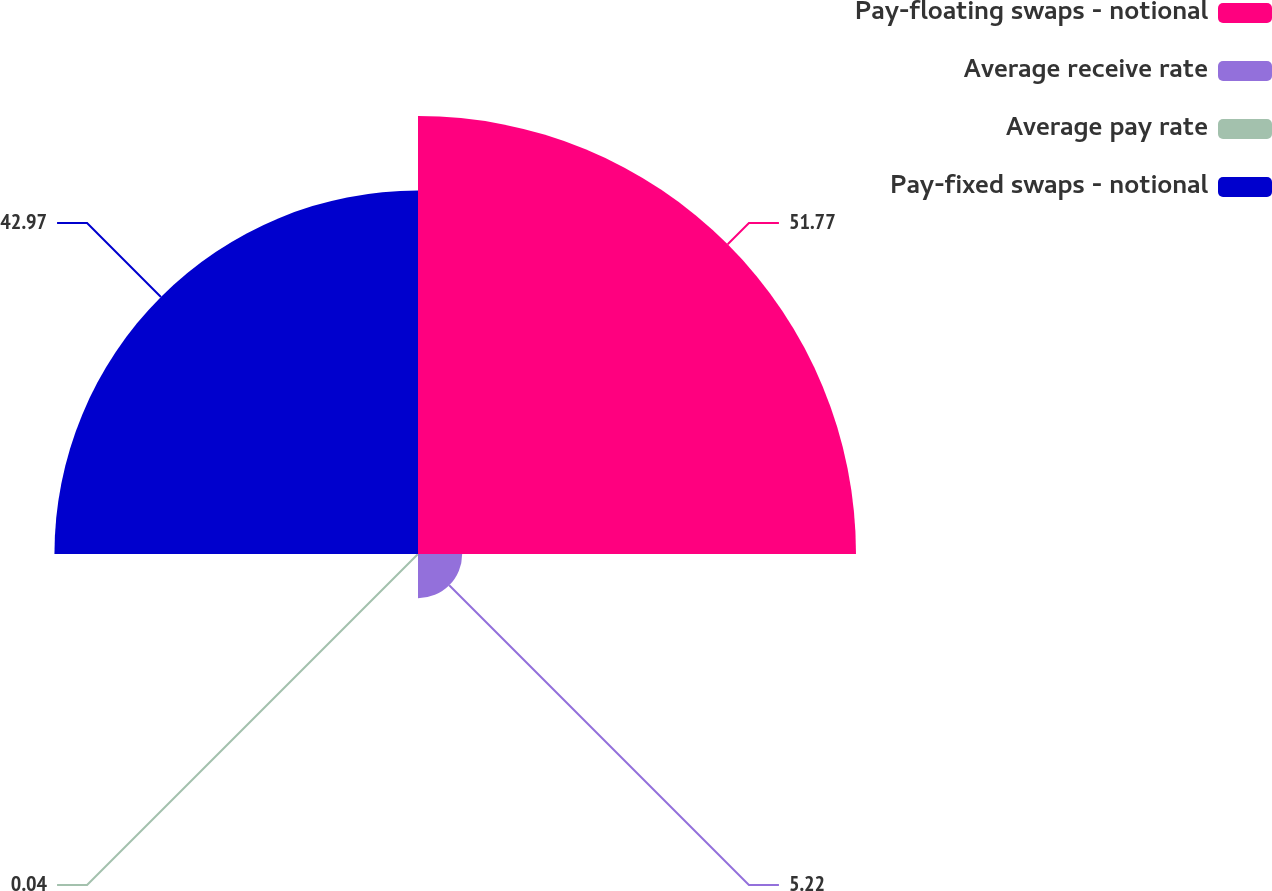Convert chart to OTSL. <chart><loc_0><loc_0><loc_500><loc_500><pie_chart><fcel>Pay-floating swaps - notional<fcel>Average receive rate<fcel>Average pay rate<fcel>Pay-fixed swaps - notional<nl><fcel>51.77%<fcel>5.22%<fcel>0.04%<fcel>42.97%<nl></chart> 